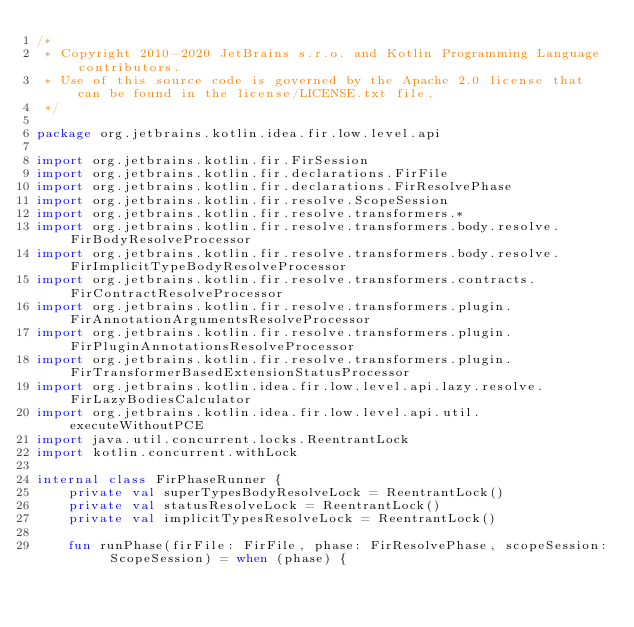Convert code to text. <code><loc_0><loc_0><loc_500><loc_500><_Kotlin_>/*
 * Copyright 2010-2020 JetBrains s.r.o. and Kotlin Programming Language contributors.
 * Use of this source code is governed by the Apache 2.0 license that can be found in the license/LICENSE.txt file.
 */

package org.jetbrains.kotlin.idea.fir.low.level.api

import org.jetbrains.kotlin.fir.FirSession
import org.jetbrains.kotlin.fir.declarations.FirFile
import org.jetbrains.kotlin.fir.declarations.FirResolvePhase
import org.jetbrains.kotlin.fir.resolve.ScopeSession
import org.jetbrains.kotlin.fir.resolve.transformers.*
import org.jetbrains.kotlin.fir.resolve.transformers.body.resolve.FirBodyResolveProcessor
import org.jetbrains.kotlin.fir.resolve.transformers.body.resolve.FirImplicitTypeBodyResolveProcessor
import org.jetbrains.kotlin.fir.resolve.transformers.contracts.FirContractResolveProcessor
import org.jetbrains.kotlin.fir.resolve.transformers.plugin.FirAnnotationArgumentsResolveProcessor
import org.jetbrains.kotlin.fir.resolve.transformers.plugin.FirPluginAnnotationsResolveProcessor
import org.jetbrains.kotlin.fir.resolve.transformers.plugin.FirTransformerBasedExtensionStatusProcessor
import org.jetbrains.kotlin.idea.fir.low.level.api.lazy.resolve.FirLazyBodiesCalculator
import org.jetbrains.kotlin.idea.fir.low.level.api.util.executeWithoutPCE
import java.util.concurrent.locks.ReentrantLock
import kotlin.concurrent.withLock

internal class FirPhaseRunner {
    private val superTypesBodyResolveLock = ReentrantLock()
    private val statusResolveLock = ReentrantLock()
    private val implicitTypesResolveLock = ReentrantLock()

    fun runPhase(firFile: FirFile, phase: FirResolvePhase, scopeSession: ScopeSession) = when (phase) {</code> 